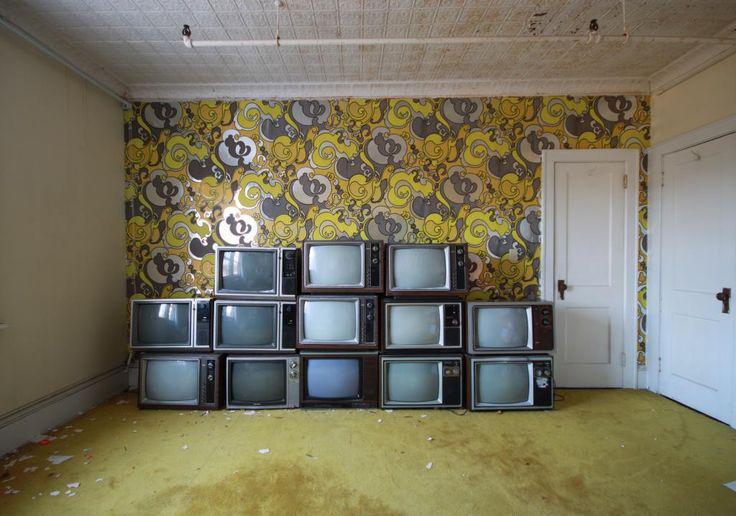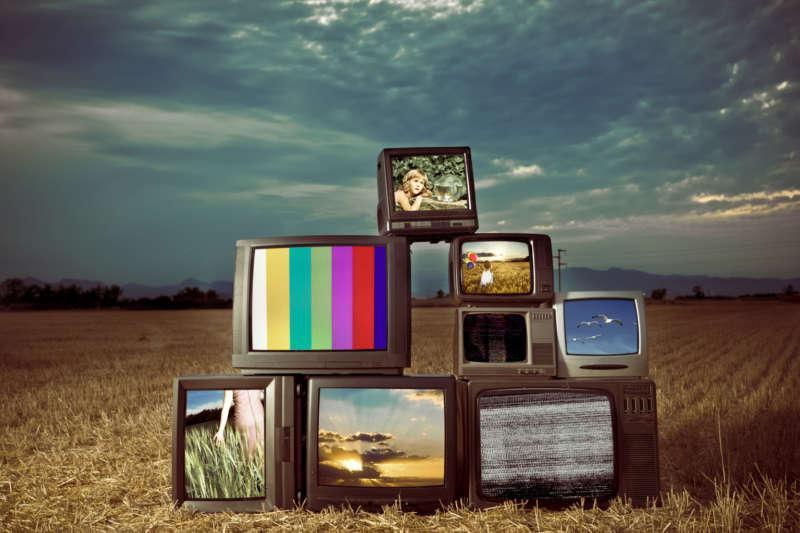The first image is the image on the left, the second image is the image on the right. Considering the images on both sides, is "A pile of old television sits in a room with a wallpapered wall behind it." valid? Answer yes or no. Yes. The first image is the image on the left, the second image is the image on the right. For the images displayed, is the sentence "There is some kind of armed seat in a room containing a stack of old-fashioned TV sets." factually correct? Answer yes or no. No. 